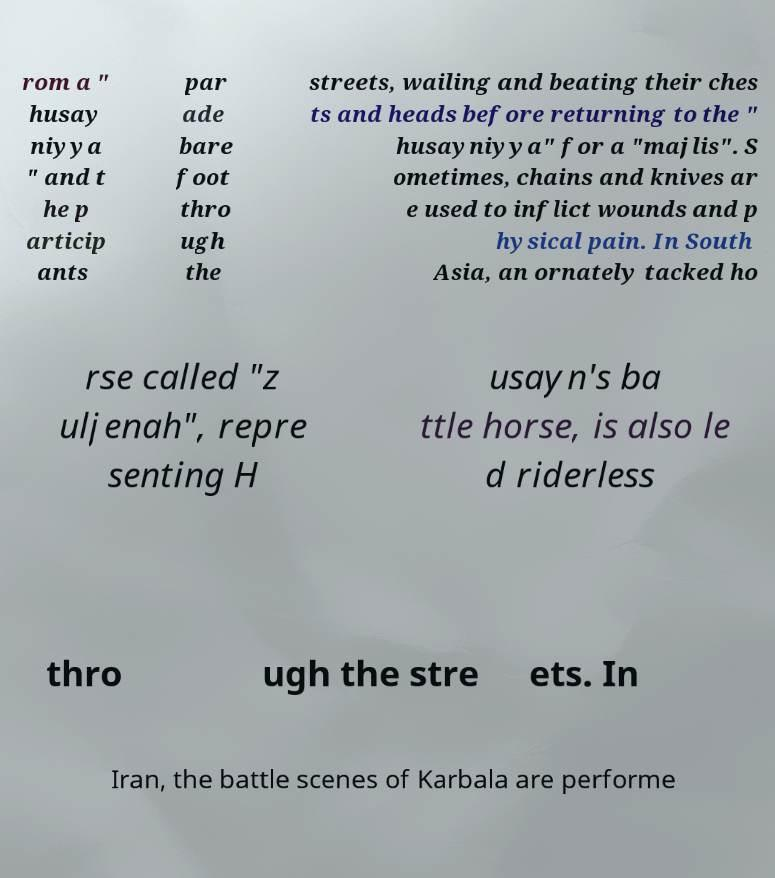Can you read and provide the text displayed in the image?This photo seems to have some interesting text. Can you extract and type it out for me? rom a " husay niyya " and t he p articip ants par ade bare foot thro ugh the streets, wailing and beating their ches ts and heads before returning to the " husayniyya" for a "majlis". S ometimes, chains and knives ar e used to inflict wounds and p hysical pain. In South Asia, an ornately tacked ho rse called "z uljenah", repre senting H usayn's ba ttle horse, is also le d riderless thro ugh the stre ets. In Iran, the battle scenes of Karbala are performe 